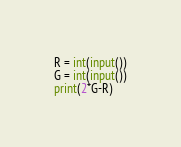Convert code to text. <code><loc_0><loc_0><loc_500><loc_500><_Python_>R = int(input())
G = int(input())
print(2*G-R)</code> 